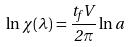Convert formula to latex. <formula><loc_0><loc_0><loc_500><loc_500>\ln \chi ( \lambda ) = \frac { t _ { f } V } { 2 \pi } \ln a</formula> 